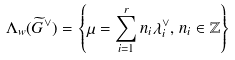<formula> <loc_0><loc_0><loc_500><loc_500>\Lambda _ { w } ( \widetilde { G } ^ { \vee } ) = \left \{ \mu = \sum _ { i = 1 } ^ { r } n _ { i } \lambda _ { i } ^ { \vee } , \, n _ { i } \in \mathbb { Z } \right \}</formula> 